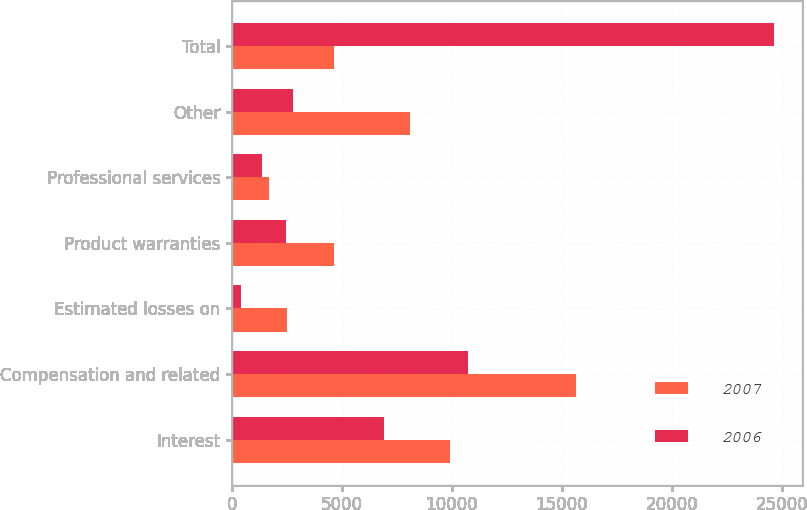<chart> <loc_0><loc_0><loc_500><loc_500><stacked_bar_chart><ecel><fcel>Interest<fcel>Compensation and related<fcel>Estimated losses on<fcel>Product warranties<fcel>Professional services<fcel>Other<fcel>Total<nl><fcel>2007<fcel>9930<fcel>15651<fcel>2498<fcel>4624<fcel>1667<fcel>8096<fcel>4624<nl><fcel>2006<fcel>6913<fcel>10719<fcel>421<fcel>2472<fcel>1373<fcel>2777<fcel>24675<nl></chart> 